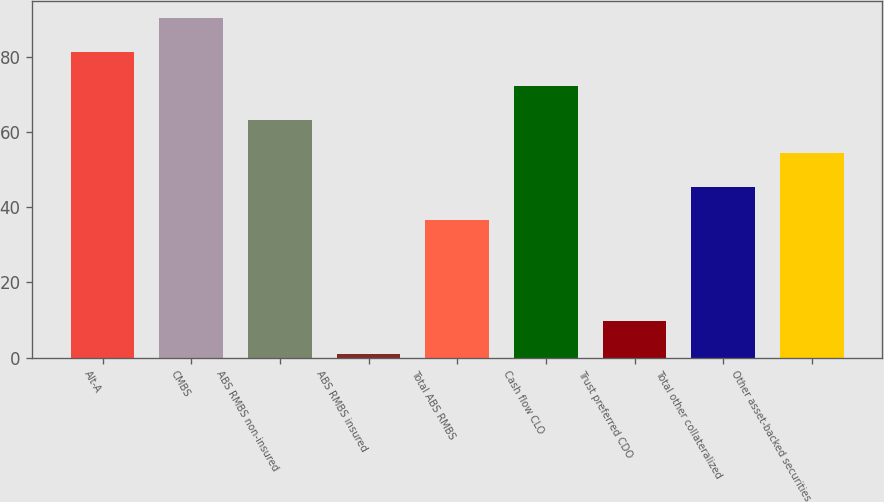<chart> <loc_0><loc_0><loc_500><loc_500><bar_chart><fcel>Alt-A<fcel>CMBS<fcel>ABS RMBS non-insured<fcel>ABS RMBS insured<fcel>Total ABS RMBS<fcel>Cash flow CLO<fcel>Trust preferred CDO<fcel>Total other collateralized<fcel>Other asset-backed securities<nl><fcel>81.2<fcel>90.3<fcel>63.32<fcel>0.9<fcel>36.5<fcel>72.26<fcel>9.84<fcel>45.44<fcel>54.38<nl></chart> 